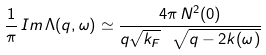<formula> <loc_0><loc_0><loc_500><loc_500>\frac { 1 } { \pi } \, I m \, \Lambda ( q , \omega ) \simeq \frac { 4 \pi \, N ^ { 2 } ( 0 ) } { q \sqrt { k _ { F } } \ \sqrt { q - 2 k ( \omega ) } }</formula> 